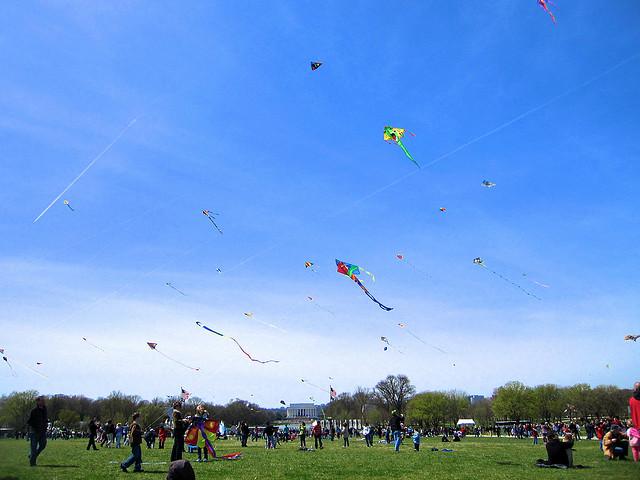Is the sky clear?
Give a very brief answer. Yes. Is the sun going to be setting soon?
Keep it brief. No. How many kites are there?
Give a very brief answer. 30. What is flying?
Be succinct. Kites. What color is the ground?
Quick response, please. Green. How many lightbulbs are needed if two are out?
Answer briefly. 0. How many people are here?
Short answer required. Many. Is it a cloudy day?
Short answer required. No. What sport is being played?
Be succinct. Kite flying. Is it overcast?
Give a very brief answer. No. Are there humans in the picture?
Be succinct. Yes. Which way is the wind blowing?
Short answer required. Right. 